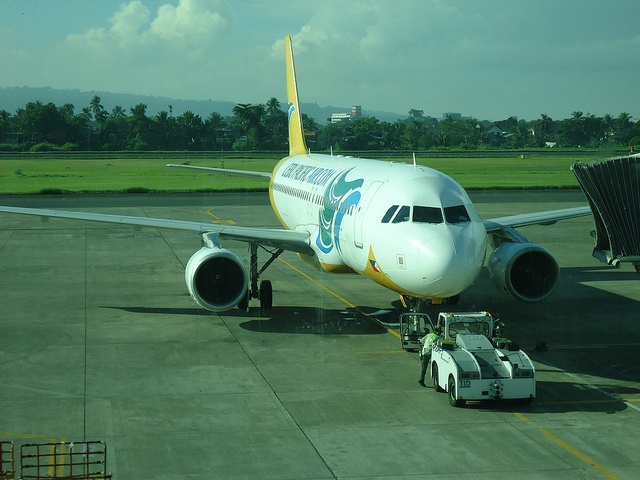Describe the objects in this image and their specific colors. I can see airplane in turquoise, beige, black, teal, and aquamarine tones, truck in turquoise, black, and teal tones, and people in turquoise, black, darkgreen, green, and lightgreen tones in this image. 